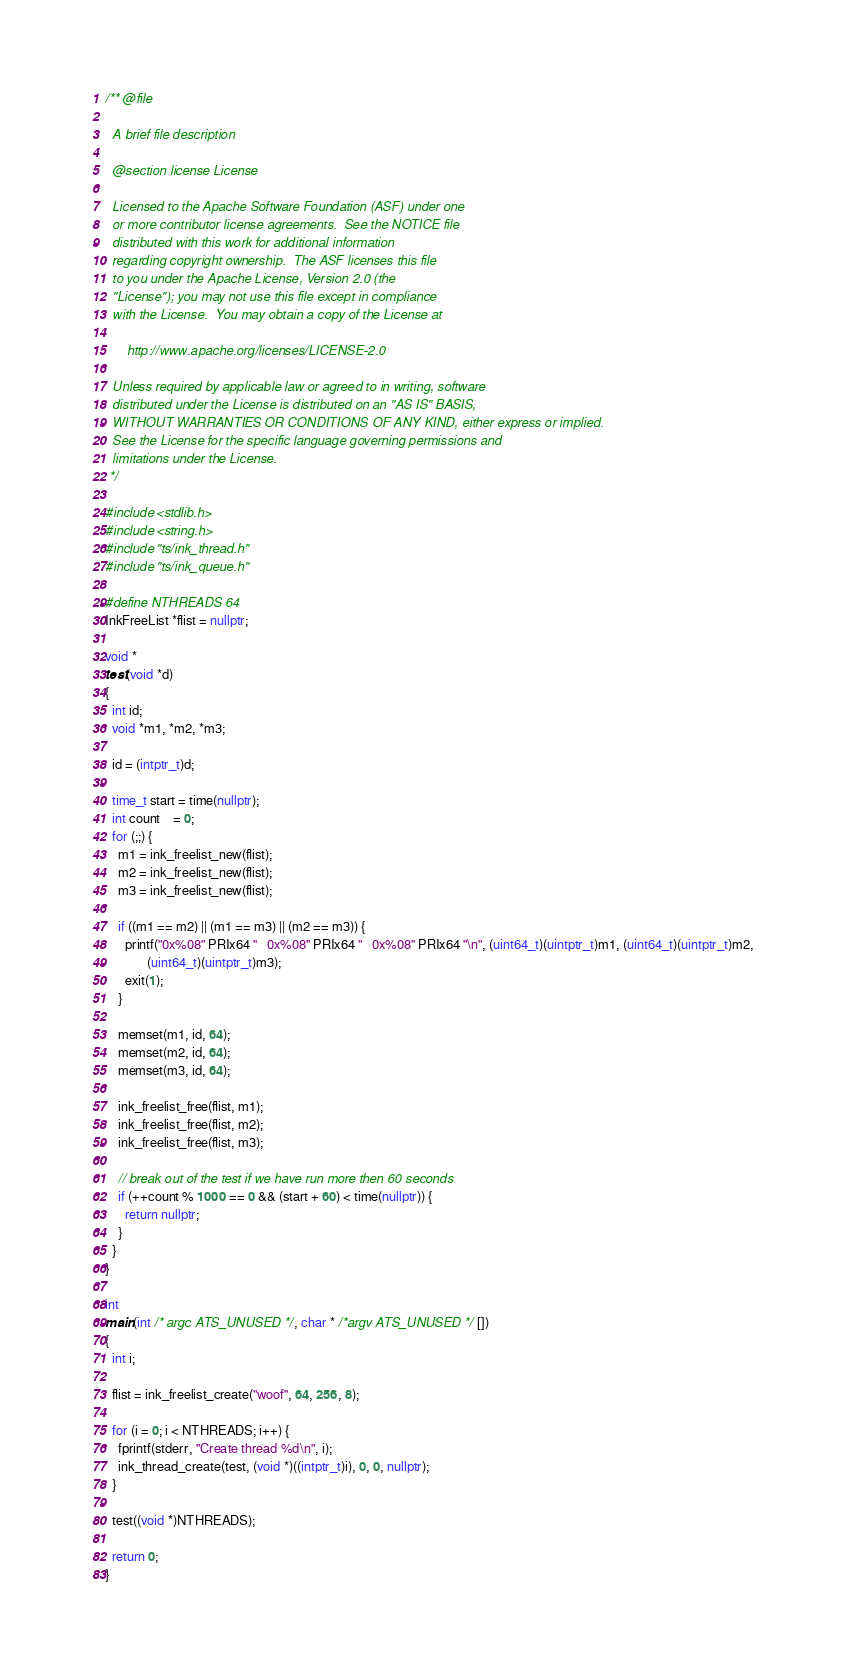Convert code to text. <code><loc_0><loc_0><loc_500><loc_500><_C++_>/** @file

  A brief file description

  @section license License

  Licensed to the Apache Software Foundation (ASF) under one
  or more contributor license agreements.  See the NOTICE file
  distributed with this work for additional information
  regarding copyright ownership.  The ASF licenses this file
  to you under the Apache License, Version 2.0 (the
  "License"); you may not use this file except in compliance
  with the License.  You may obtain a copy of the License at

      http://www.apache.org/licenses/LICENSE-2.0

  Unless required by applicable law or agreed to in writing, software
  distributed under the License is distributed on an "AS IS" BASIS,
  WITHOUT WARRANTIES OR CONDITIONS OF ANY KIND, either express or implied.
  See the License for the specific language governing permissions and
  limitations under the License.
 */

#include <stdlib.h>
#include <string.h>
#include "ts/ink_thread.h"
#include "ts/ink_queue.h"

#define NTHREADS 64
InkFreeList *flist = nullptr;

void *
test(void *d)
{
  int id;
  void *m1, *m2, *m3;

  id = (intptr_t)d;

  time_t start = time(nullptr);
  int count    = 0;
  for (;;) {
    m1 = ink_freelist_new(flist);
    m2 = ink_freelist_new(flist);
    m3 = ink_freelist_new(flist);

    if ((m1 == m2) || (m1 == m3) || (m2 == m3)) {
      printf("0x%08" PRIx64 "   0x%08" PRIx64 "   0x%08" PRIx64 "\n", (uint64_t)(uintptr_t)m1, (uint64_t)(uintptr_t)m2,
             (uint64_t)(uintptr_t)m3);
      exit(1);
    }

    memset(m1, id, 64);
    memset(m2, id, 64);
    memset(m3, id, 64);

    ink_freelist_free(flist, m1);
    ink_freelist_free(flist, m2);
    ink_freelist_free(flist, m3);

    // break out of the test if we have run more then 60 seconds
    if (++count % 1000 == 0 && (start + 60) < time(nullptr)) {
      return nullptr;
    }
  }
}

int
main(int /* argc ATS_UNUSED */, char * /*argv ATS_UNUSED */ [])
{
  int i;

  flist = ink_freelist_create("woof", 64, 256, 8);

  for (i = 0; i < NTHREADS; i++) {
    fprintf(stderr, "Create thread %d\n", i);
    ink_thread_create(test, (void *)((intptr_t)i), 0, 0, nullptr);
  }

  test((void *)NTHREADS);

  return 0;
}
</code> 